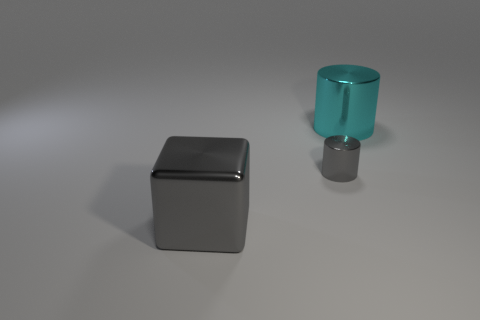Add 1 big metal cylinders. How many objects exist? 4 Subtract all cylinders. How many objects are left? 1 Add 2 big cyan metallic cylinders. How many big cyan metallic cylinders exist? 3 Subtract 1 gray cylinders. How many objects are left? 2 Subtract all big objects. Subtract all tiny yellow objects. How many objects are left? 1 Add 2 cylinders. How many cylinders are left? 4 